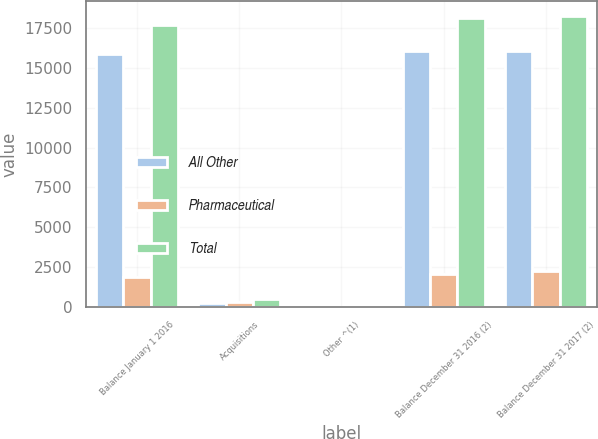<chart> <loc_0><loc_0><loc_500><loc_500><stacked_bar_chart><ecel><fcel>Balance January 1 2016<fcel>Acquisitions<fcel>Other ^(1)<fcel>Balance December 31 2016 (2)<fcel>Balance December 31 2017 (2)<nl><fcel>All Other<fcel>15862<fcel>207<fcel>6<fcel>16075<fcel>16066<nl><fcel>Pharmaceutical<fcel>1861<fcel>275<fcel>2<fcel>2087<fcel>2218<nl><fcel>Total<fcel>17723<fcel>482<fcel>4<fcel>18162<fcel>18284<nl></chart> 